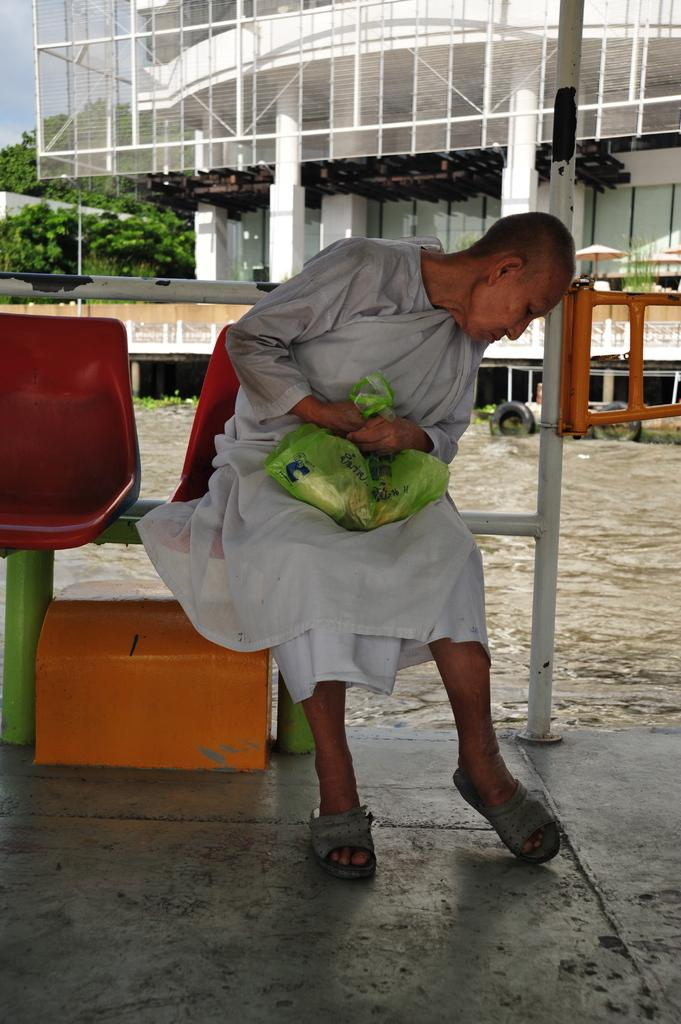What is the person in the image wearing? The person is wearing a white dress. What is the person doing in the image? The person is sitting on a chair. What color is the chair cover? The chair has a green cover. What can be seen in the background of the image? There is a white building in the background of the image. What type of pear is the person holding in the image? There is no pear present in the image; the person is wearing a white dress and sitting on a chair with a green-covered chair. 